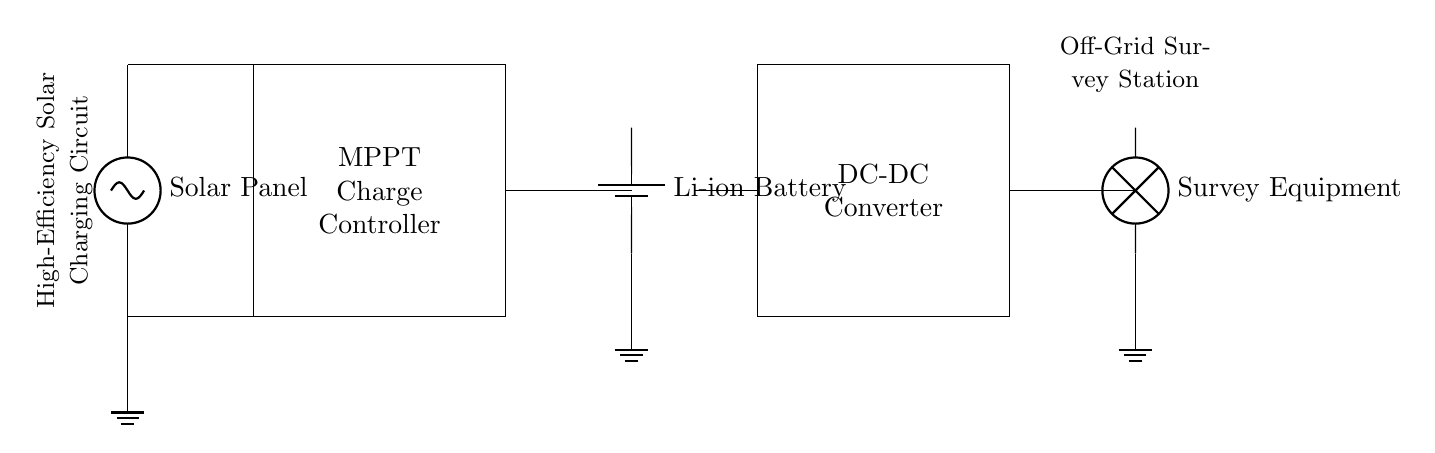What is the main component that converts solar energy? The solar panel is the primary component responsible for converting solar energy into electrical energy in this circuit.
Answer: Solar Panel What type of battery is used in the circuit? The circuit specifies the use of a Lithium-ion battery, which is known for its high energy density and efficiency in energy storage.
Answer: Li-ion Battery What is the purpose of the MPPT charge controller? The Maximum Power Point Tracking (MPPT) charge controller optimizes the power output from the solar panel to ensure efficient charging of the battery.
Answer: Optimize charging What type of load is connected to this circuit? The load connected in this circuit is labeled as survey equipment, indicating that the circuit supplies power for geological survey activities.
Answer: Survey Equipment How many main components are involved in this circuit? The circuit includes four main components: the solar panel, MPPT charge controller, battery, and DC-DC converter, which all work together to store and supply energy.
Answer: Four What role does the DC-DC converter play in the circuit? The DC-DC converter adjusts the voltage from the battery to a suitable level for the connected survey equipment, ensuring proper functionality.
Answer: Voltage adjustment What is the significance of having a ground connection in circuits like this? Ground connections ensure safety by providing a reference point for voltage and a path for fault currents, which helps prevent electrical shock and equipment damage.
Answer: Safety reference 